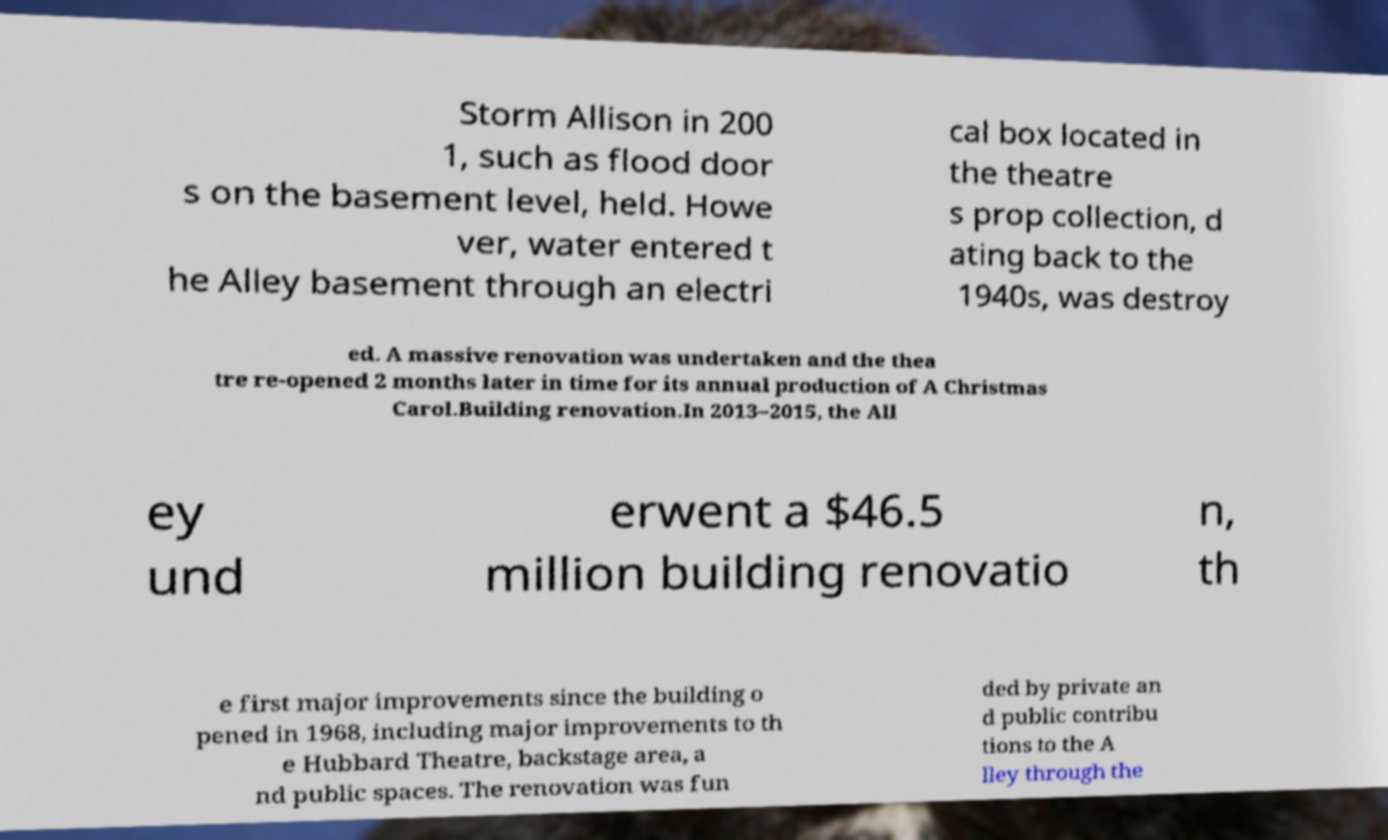For documentation purposes, I need the text within this image transcribed. Could you provide that? Storm Allison in 200 1, such as flood door s on the basement level, held. Howe ver, water entered t he Alley basement through an electri cal box located in the theatre s prop collection, d ating back to the 1940s, was destroy ed. A massive renovation was undertaken and the thea tre re-opened 2 months later in time for its annual production of A Christmas Carol.Building renovation.In 2013–2015, the All ey und erwent a $46.5 million building renovatio n, th e first major improvements since the building o pened in 1968, including major improvements to th e Hubbard Theatre, backstage area, a nd public spaces. The renovation was fun ded by private an d public contribu tions to the A lley through the 